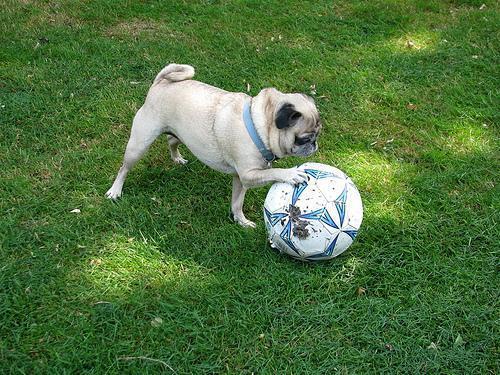How many balls are visible?
Give a very brief answer. 1. 